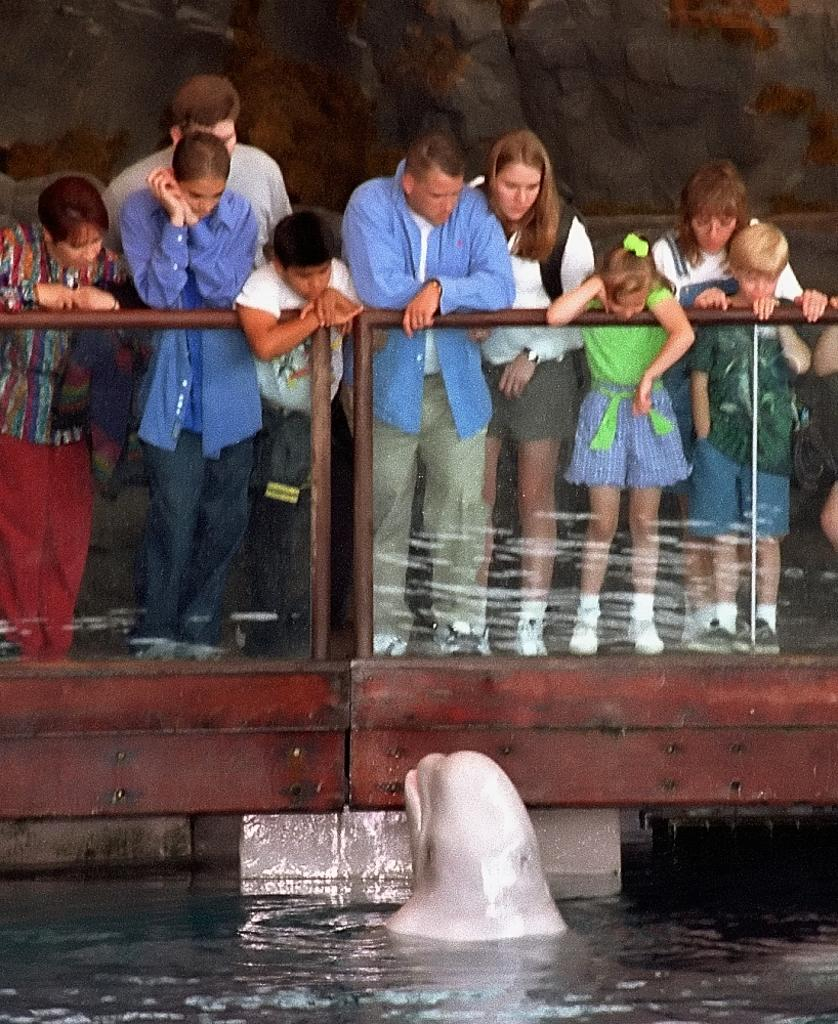What animal can be seen in the water in the image? There is a dolphin in the water in the image. What structures are visible in the background of the image? There is a fence and a wall in the background of the image. Are there any people present in the image? Yes, there are people in the background of the image. What type of map can be seen in the image? There is no map present in the image; it features a dolphin in the water and structures in the background. 